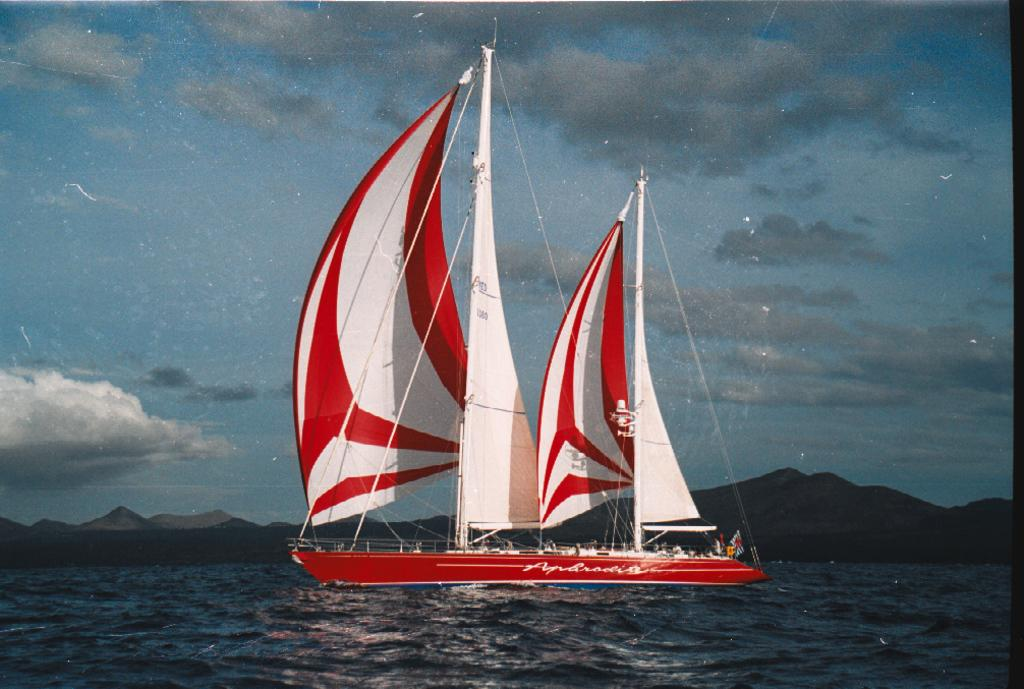What type of view is shown in the image? The image is an outside view. What can be seen on the water in the image? There is a ship on the water. What type of landscape feature is visible in the background? There are hills visible in the background. What is visible at the top of the image? The sky is visible at the top of the image. What can be observed in the sky? Clouds are present in the sky. Where is the market located in the image? There is no market present in the image. What type of gold can be seen on the ship in the image? There is no gold present on the ship in the image. 